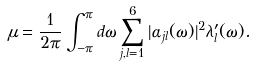<formula> <loc_0><loc_0><loc_500><loc_500>\mu = \frac { 1 } { 2 \pi } \int _ { - \pi } ^ { \pi } d \omega \sum _ { j , l = 1 } ^ { 6 } | \alpha _ { j l } ( \omega ) | ^ { 2 } \lambda _ { l } ^ { \prime } ( \omega ) .</formula> 